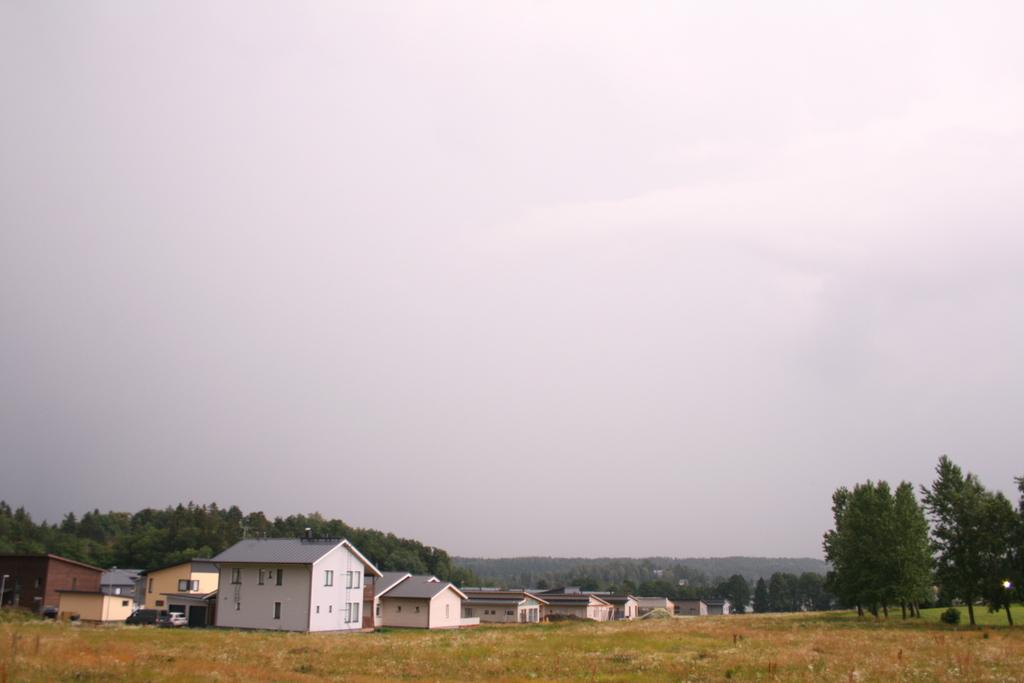What is located at the bottom of the image? There are houses, vehicles, trees, and grass at the bottom of the image. What can be seen in the sky in the image? The sky is visible in the image, and clouds are present. What type of wood is the creature using to cook in the image? There is no creature or cooking activity present in the image. 